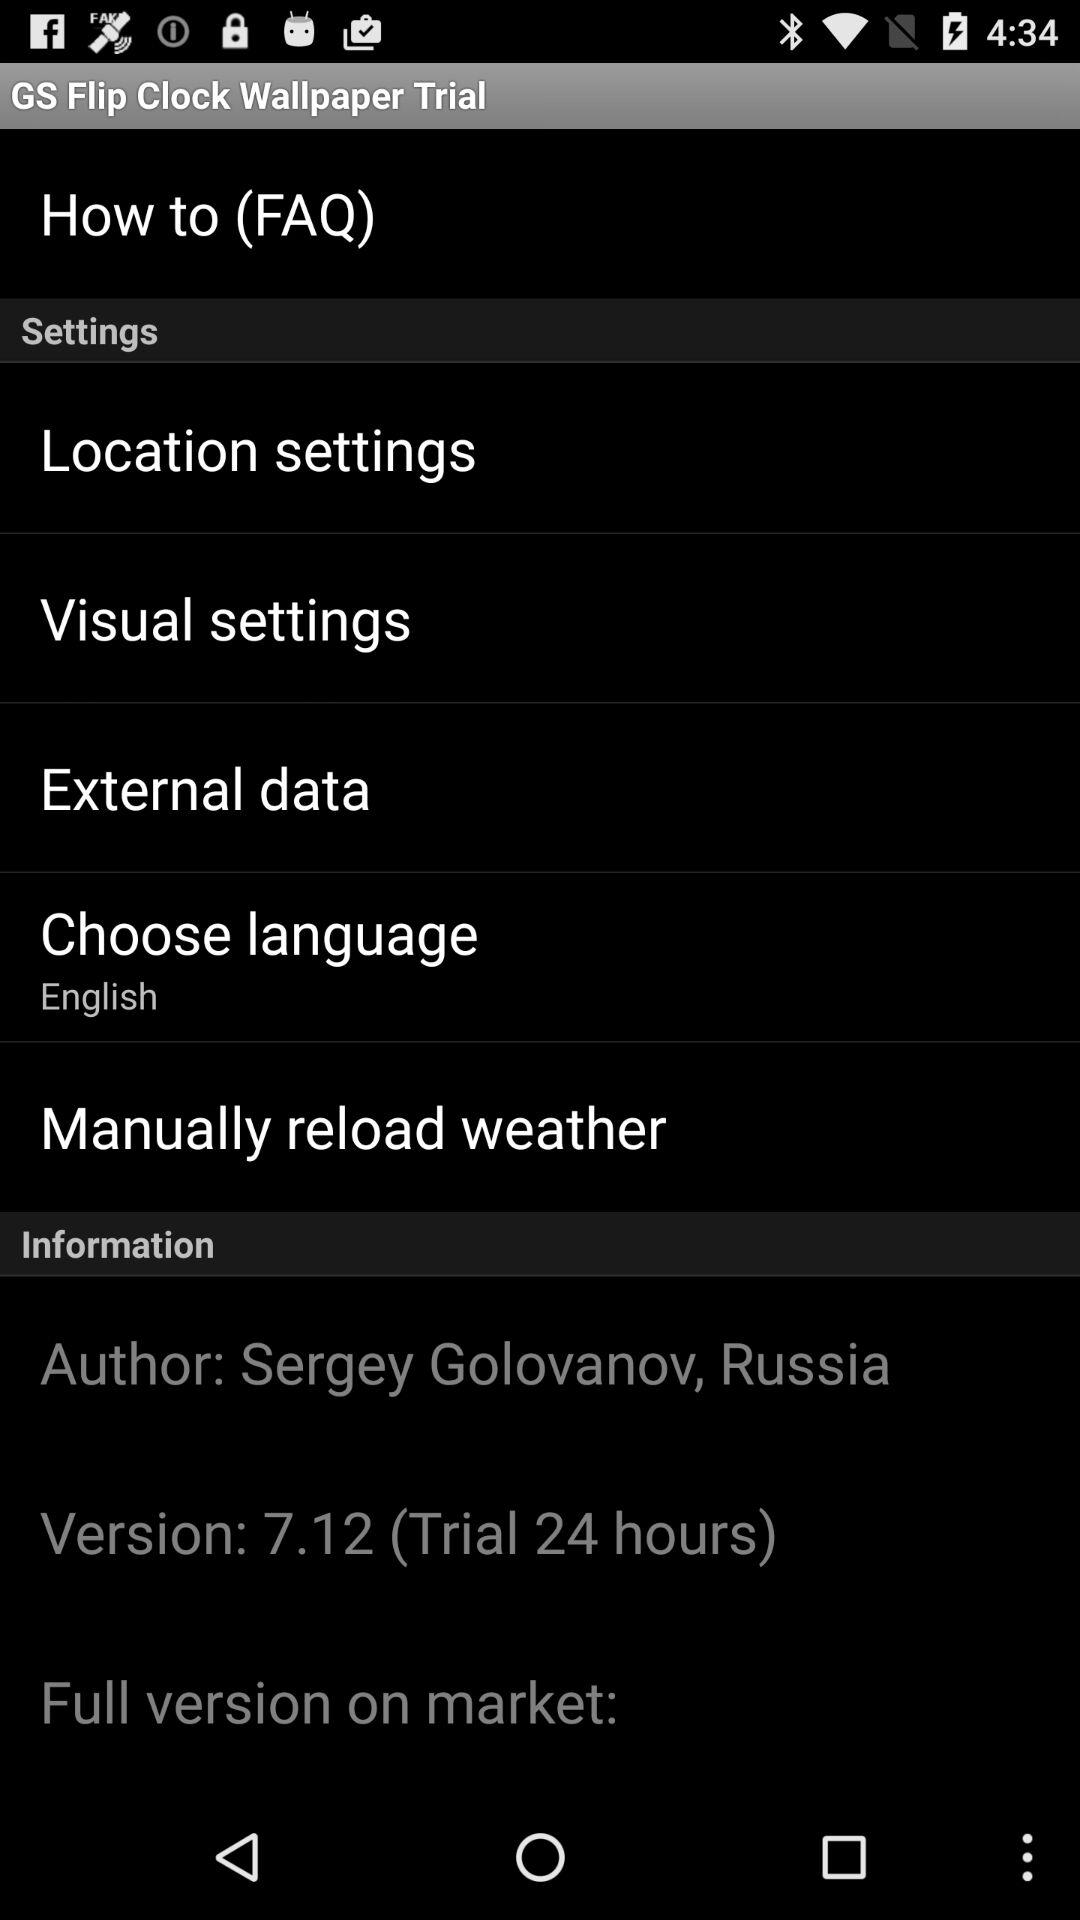What is the name of the application? The name of the application is "GS Flip Clock Wallpaper Trial". 